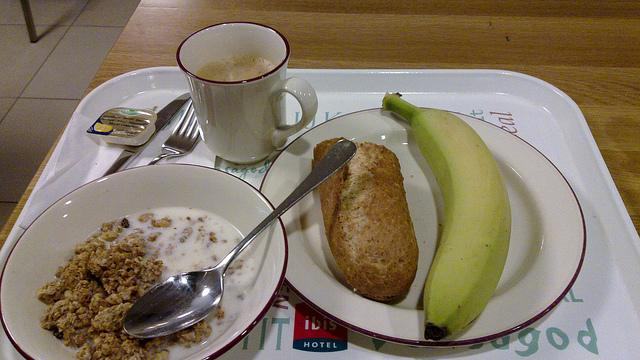What is on the plate all the way to the right? banana 